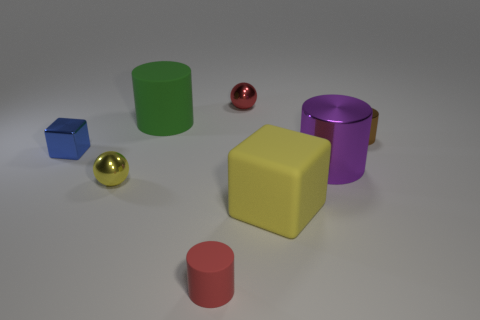There is a rubber thing that is right of the small red cylinder; what shape is it?
Offer a terse response. Cube. Do the metallic sphere behind the large purple object and the small shiny cylinder have the same color?
Offer a very short reply. No. What material is the thing that is the same color as the big rubber cube?
Keep it short and to the point. Metal. Do the sphere in front of the green rubber thing and the yellow matte object have the same size?
Your answer should be compact. No. Is there a large metallic sphere of the same color as the small shiny cylinder?
Offer a terse response. No. There is a large thing that is in front of the large purple shiny cylinder; is there a small red shiny object that is right of it?
Your answer should be compact. No. Is there a large cube made of the same material as the red cylinder?
Provide a succinct answer. Yes. What is the material of the red thing that is right of the tiny cylinder on the left side of the brown thing?
Provide a succinct answer. Metal. The cylinder that is to the right of the green matte cylinder and on the left side of the large purple metallic object is made of what material?
Offer a very short reply. Rubber. Are there the same number of blue metal blocks on the right side of the big metal thing and tiny red things?
Offer a very short reply. No. 